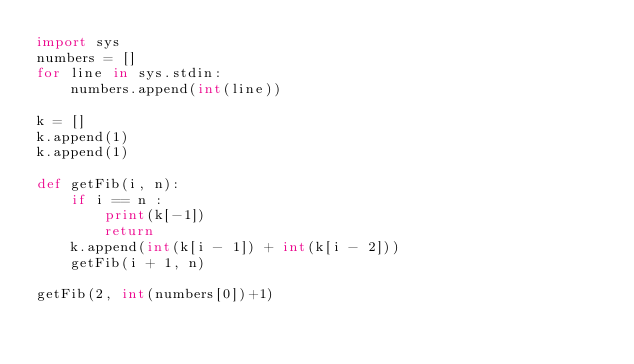<code> <loc_0><loc_0><loc_500><loc_500><_Python_>import sys
numbers = []
for line in sys.stdin:
	numbers.append(int(line))

k = []
k.append(1)
k.append(1)

def getFib(i, n):
    if i == n :
        print(k[-1])
        return
    k.append(int(k[i - 1]) + int(k[i - 2]))
    getFib(i + 1, n)

getFib(2, int(numbers[0])+1)
</code> 